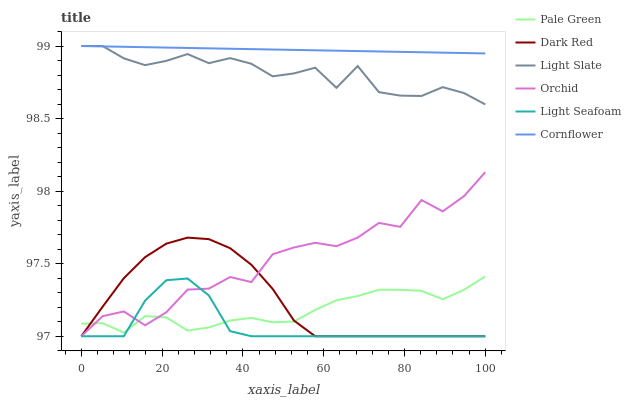Does Light Seafoam have the minimum area under the curve?
Answer yes or no. Yes. Does Cornflower have the maximum area under the curve?
Answer yes or no. Yes. Does Light Slate have the minimum area under the curve?
Answer yes or no. No. Does Light Slate have the maximum area under the curve?
Answer yes or no. No. Is Cornflower the smoothest?
Answer yes or no. Yes. Is Orchid the roughest?
Answer yes or no. Yes. Is Light Slate the smoothest?
Answer yes or no. No. Is Light Slate the roughest?
Answer yes or no. No. Does Dark Red have the lowest value?
Answer yes or no. Yes. Does Light Slate have the lowest value?
Answer yes or no. No. Does Light Slate have the highest value?
Answer yes or no. Yes. Does Dark Red have the highest value?
Answer yes or no. No. Is Light Seafoam less than Cornflower?
Answer yes or no. Yes. Is Light Slate greater than Orchid?
Answer yes or no. Yes. Does Pale Green intersect Light Seafoam?
Answer yes or no. Yes. Is Pale Green less than Light Seafoam?
Answer yes or no. No. Is Pale Green greater than Light Seafoam?
Answer yes or no. No. Does Light Seafoam intersect Cornflower?
Answer yes or no. No. 